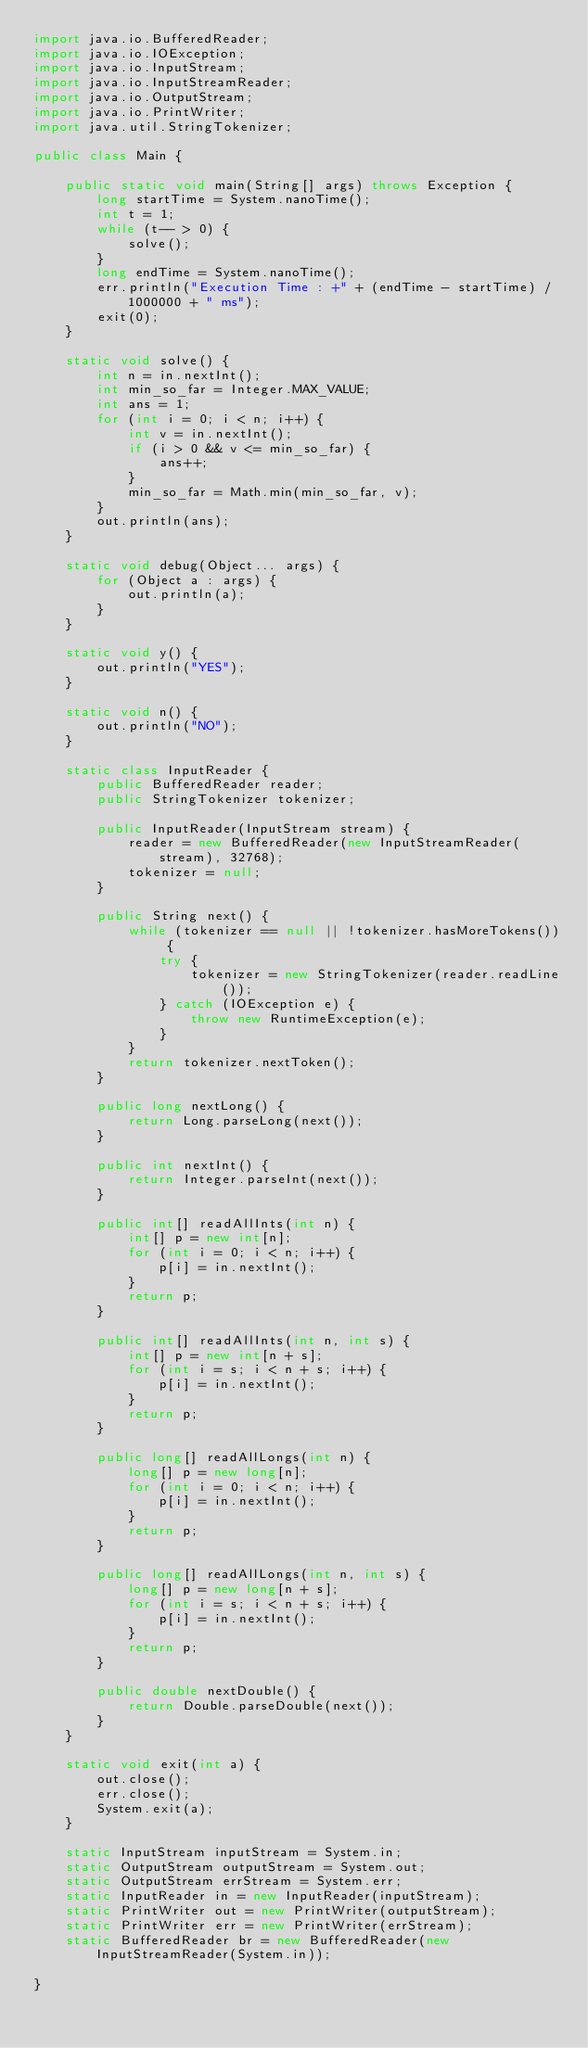<code> <loc_0><loc_0><loc_500><loc_500><_Java_>import java.io.BufferedReader;
import java.io.IOException;
import java.io.InputStream;
import java.io.InputStreamReader;
import java.io.OutputStream;
import java.io.PrintWriter;
import java.util.StringTokenizer;

public class Main {

    public static void main(String[] args) throws Exception {
        long startTime = System.nanoTime();
        int t = 1;
        while (t-- > 0) {
            solve();
        }
        long endTime = System.nanoTime();
        err.println("Execution Time : +" + (endTime - startTime) / 1000000 + " ms");
        exit(0);
    }

    static void solve() {
        int n = in.nextInt();
        int min_so_far = Integer.MAX_VALUE;
        int ans = 1;
        for (int i = 0; i < n; i++) {
            int v = in.nextInt();
            if (i > 0 && v <= min_so_far) {
                ans++;
            }
            min_so_far = Math.min(min_so_far, v);
        }
        out.println(ans);
    }

    static void debug(Object... args) {
        for (Object a : args) {
            out.println(a);
        }
    }

    static void y() {
        out.println("YES");
    }

    static void n() {
        out.println("NO");
    }

    static class InputReader {
        public BufferedReader reader;
        public StringTokenizer tokenizer;

        public InputReader(InputStream stream) {
            reader = new BufferedReader(new InputStreamReader(stream), 32768);
            tokenizer = null;
        }

        public String next() {
            while (tokenizer == null || !tokenizer.hasMoreTokens()) {
                try {
                    tokenizer = new StringTokenizer(reader.readLine());
                } catch (IOException e) {
                    throw new RuntimeException(e);
                }
            }
            return tokenizer.nextToken();
        }

        public long nextLong() {
            return Long.parseLong(next());
        }

        public int nextInt() {
            return Integer.parseInt(next());
        }

        public int[] readAllInts(int n) {
            int[] p = new int[n];
            for (int i = 0; i < n; i++) {
                p[i] = in.nextInt();
            }
            return p;
        }

        public int[] readAllInts(int n, int s) {
            int[] p = new int[n + s];
            for (int i = s; i < n + s; i++) {
                p[i] = in.nextInt();
            }
            return p;
        }

        public long[] readAllLongs(int n) {
            long[] p = new long[n];
            for (int i = 0; i < n; i++) {
                p[i] = in.nextInt();
            }
            return p;
        }

        public long[] readAllLongs(int n, int s) {
            long[] p = new long[n + s];
            for (int i = s; i < n + s; i++) {
                p[i] = in.nextInt();
            }
            return p;
        }

        public double nextDouble() {
            return Double.parseDouble(next());
        }
    }

    static void exit(int a) {
        out.close();
        err.close();
        System.exit(a);
    }

    static InputStream inputStream = System.in;
    static OutputStream outputStream = System.out;
    static OutputStream errStream = System.err;
    static InputReader in = new InputReader(inputStream);
    static PrintWriter out = new PrintWriter(outputStream);
    static PrintWriter err = new PrintWriter(errStream);
    static BufferedReader br = new BufferedReader(new InputStreamReader(System.in));

}
</code> 